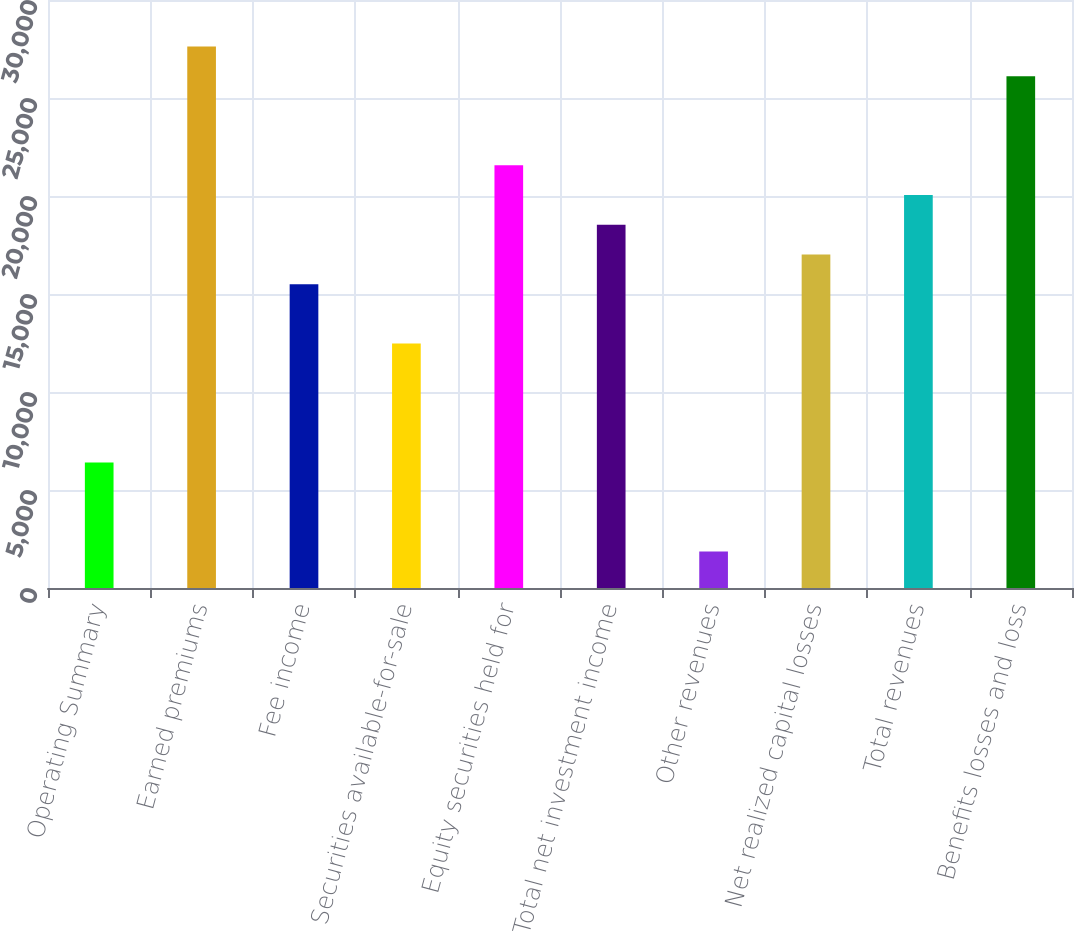Convert chart. <chart><loc_0><loc_0><loc_500><loc_500><bar_chart><fcel>Operating Summary<fcel>Earned premiums<fcel>Fee income<fcel>Securities available-for-sale<fcel>Equity securities held for<fcel>Total net investment income<fcel>Other revenues<fcel>Net realized capital losses<fcel>Total revenues<fcel>Benefits losses and loss<nl><fcel>6407<fcel>27631<fcel>15503<fcel>12471<fcel>21567<fcel>18535<fcel>1859<fcel>17019<fcel>20051<fcel>26115<nl></chart> 